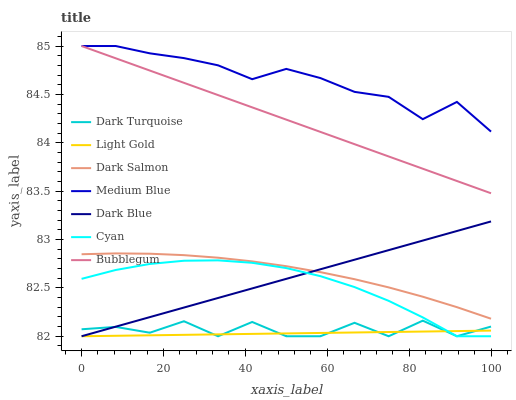Does Light Gold have the minimum area under the curve?
Answer yes or no. Yes. Does Medium Blue have the maximum area under the curve?
Answer yes or no. Yes. Does Dark Salmon have the minimum area under the curve?
Answer yes or no. No. Does Dark Salmon have the maximum area under the curve?
Answer yes or no. No. Is Dark Blue the smoothest?
Answer yes or no. Yes. Is Dark Turquoise the roughest?
Answer yes or no. Yes. Is Medium Blue the smoothest?
Answer yes or no. No. Is Medium Blue the roughest?
Answer yes or no. No. Does Dark Turquoise have the lowest value?
Answer yes or no. Yes. Does Dark Salmon have the lowest value?
Answer yes or no. No. Does Bubblegum have the highest value?
Answer yes or no. Yes. Does Dark Salmon have the highest value?
Answer yes or no. No. Is Dark Salmon less than Bubblegum?
Answer yes or no. Yes. Is Medium Blue greater than Dark Salmon?
Answer yes or no. Yes. Does Dark Salmon intersect Dark Blue?
Answer yes or no. Yes. Is Dark Salmon less than Dark Blue?
Answer yes or no. No. Is Dark Salmon greater than Dark Blue?
Answer yes or no. No. Does Dark Salmon intersect Bubblegum?
Answer yes or no. No. 